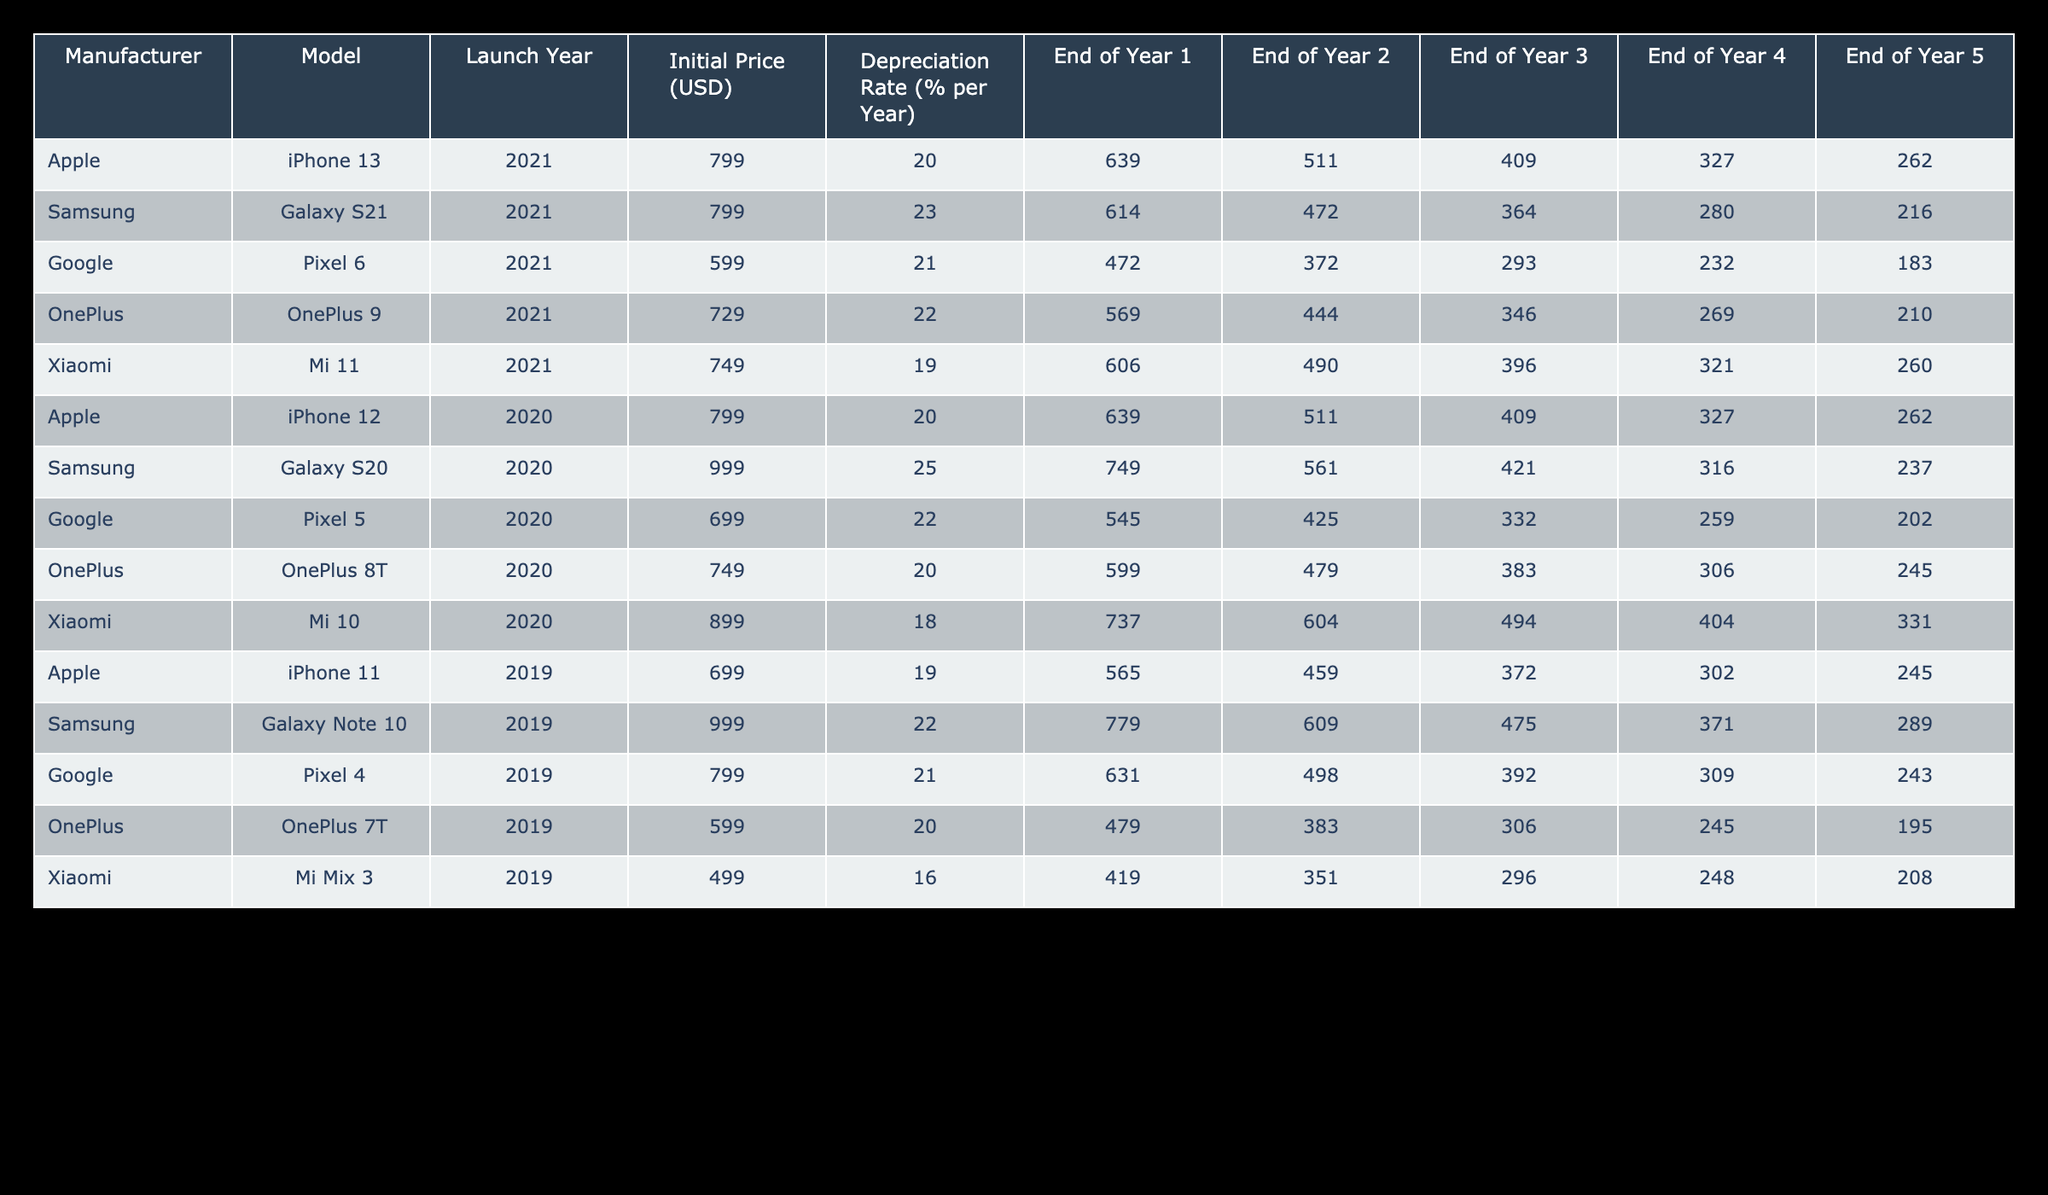What is the initial price of the Samsung Galaxy S21? The initial price of the Samsung Galaxy S21 can be found in the "Initial Price (USD)" column for the respective model. Referring to the table, the price listed is 799 USD.
Answer: 799 USD What is the depreciation rate of the Xiaomi Mi 11? The depreciation rate is located in the "Depreciation Rate (% per Year)" column of the table. For the Xiaomi Mi 11, the depreciation rate is 19%.
Answer: 19% Which smartphone retains more value after three years: the OnePlus 9 or the Google Pixel 6? We need to look at the "End of Year 3" values for both smartphones. The OnePlus 9 is valued at 346 USD after three years, while the Google Pixel 6 is at 293 USD. Comparing these two, the OnePlus 9 retains more value.
Answer: OnePlus 9 How much did the Apple iPhone 12 depreciate in value after five years? The depreciation value can be calculated by subtracting the final value at the end of year 5 from the initial price. The initial price is 799 USD, and at the end of year 5 it is valued at 262 USD. Calculating the depreciation: 799 - 262 = 537 USD.
Answer: 537 USD Is it true that the Google Pixel 5 has a higher initial price than the OnePlus 8T? We can check the "Initial Price (USD)" for both models. The Google Pixel 5 has an initial price of 699 USD, while the OnePlus 8T has an initial price of 749 USD. Since 699 is less than 749, the statement is false.
Answer: False What is the average retained value after two years for all smartphones listed? To find the average value after two years, we first sum the values at the end of Year 2 for all smartphones: 511 + 472 + 372 + 444 + 490 + 511 + 561 + 425 + 479 + 604 + 459 + 609 + 498 + 383 + 351 = 6977. There are 15 smartphones, so we divide the total by 15: 6977 / 15 = about 465.13.
Answer: 465.13 Which smartphone has the lowest retained value after four years? Looking at the "End of Year 4" values, we see the lowest value among them. The OnePlus 7T has a final value of 245 USD, which is lower than any other smartphone listed.
Answer: OnePlus 7T Which manufacturer had the highest initial price among the listed models? By examining the "Initial Price (USD)" column, we see that Samsung's Galaxy S20 has the highest initial price at 999 USD, compared to other models.
Answer: Samsung Galaxy S20 How much value does the Xiaomi Mi Mix 3 retain after five years? Referring to the "End of Year 5" column for the Xiaomi Mi Mix 3, we find it retains a value of 208 USD after five years.
Answer: 208 USD 